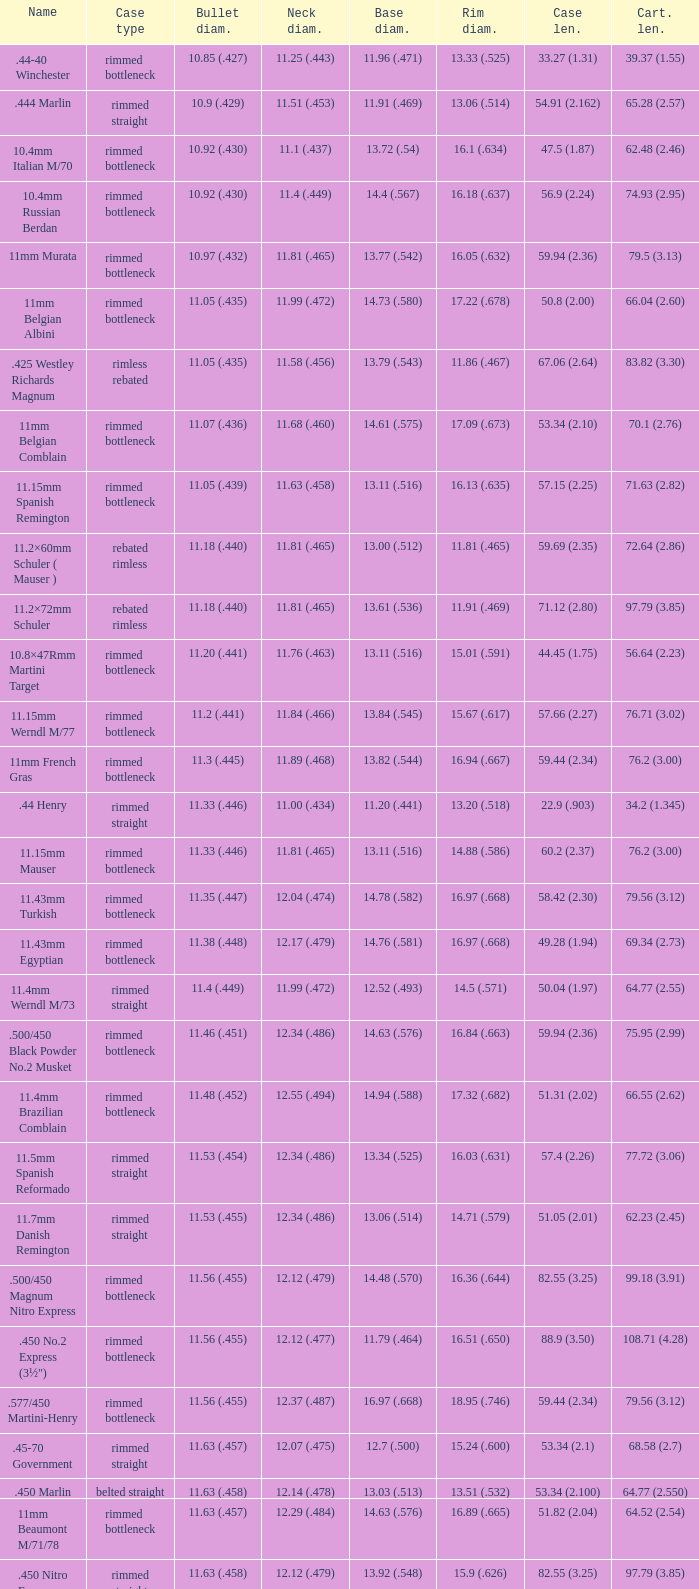Which Bullet diameter has a Name of 11.4mm werndl m/73? 11.4 (.449). 